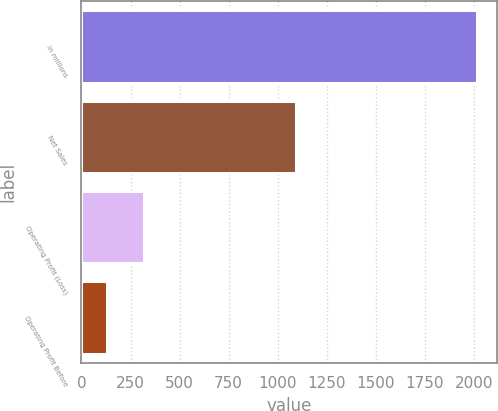Convert chart. <chart><loc_0><loc_0><loc_500><loc_500><bar_chart><fcel>In millions<fcel>Net Sales<fcel>Operating Profit (Loss)<fcel>Operating Profit Before<nl><fcel>2016<fcel>1092<fcel>318.6<fcel>130<nl></chart> 